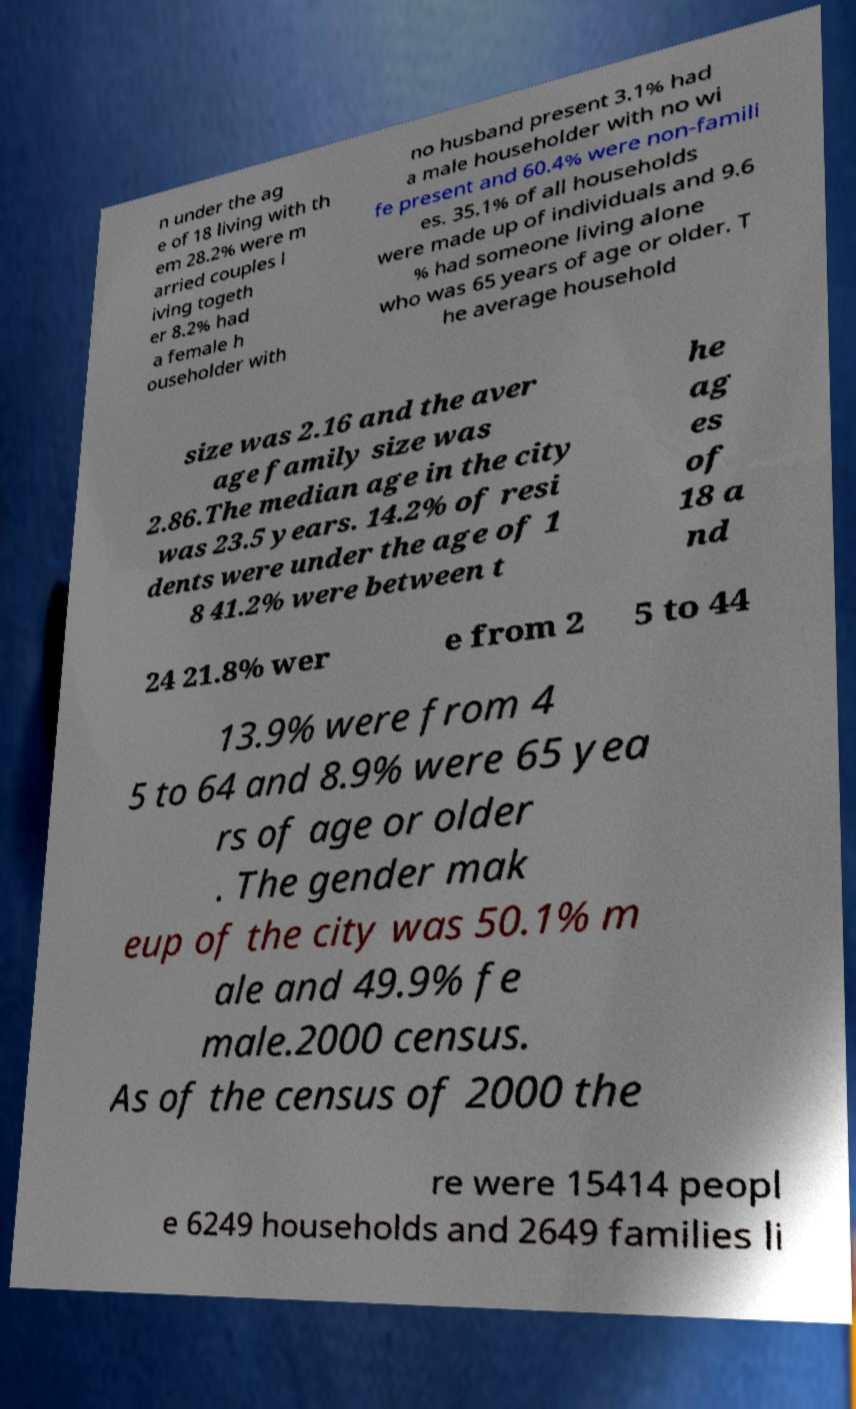For documentation purposes, I need the text within this image transcribed. Could you provide that? n under the ag e of 18 living with th em 28.2% were m arried couples l iving togeth er 8.2% had a female h ouseholder with no husband present 3.1% had a male householder with no wi fe present and 60.4% were non-famili es. 35.1% of all households were made up of individuals and 9.6 % had someone living alone who was 65 years of age or older. T he average household size was 2.16 and the aver age family size was 2.86.The median age in the city was 23.5 years. 14.2% of resi dents were under the age of 1 8 41.2% were between t he ag es of 18 a nd 24 21.8% wer e from 2 5 to 44 13.9% were from 4 5 to 64 and 8.9% were 65 yea rs of age or older . The gender mak eup of the city was 50.1% m ale and 49.9% fe male.2000 census. As of the census of 2000 the re were 15414 peopl e 6249 households and 2649 families li 